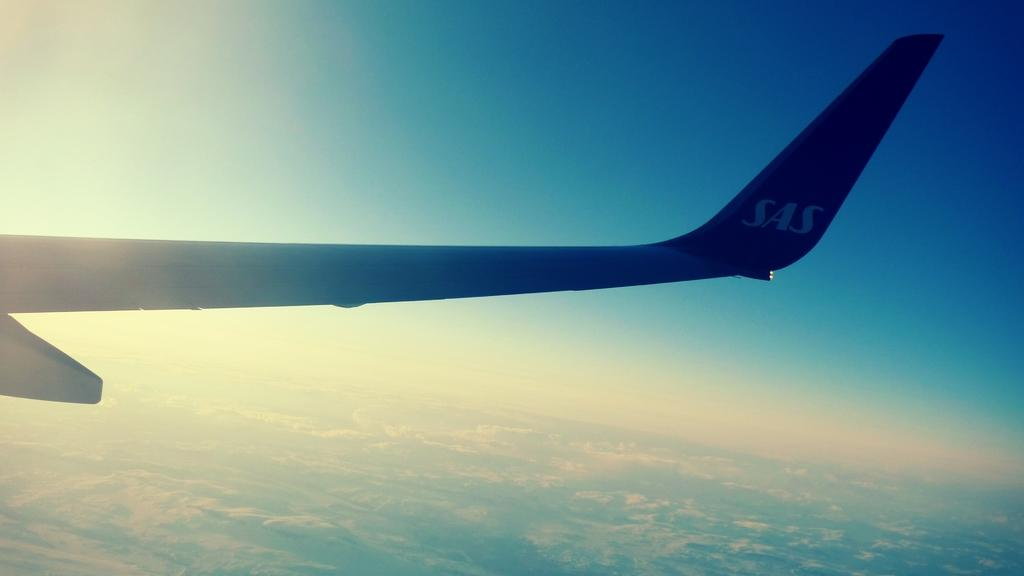<image>
Give a short and clear explanation of the subsequent image. an SAS airplane wing tip from the airplane window 